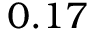Convert formula to latex. <formula><loc_0><loc_0><loc_500><loc_500>0 . 1 7</formula> 